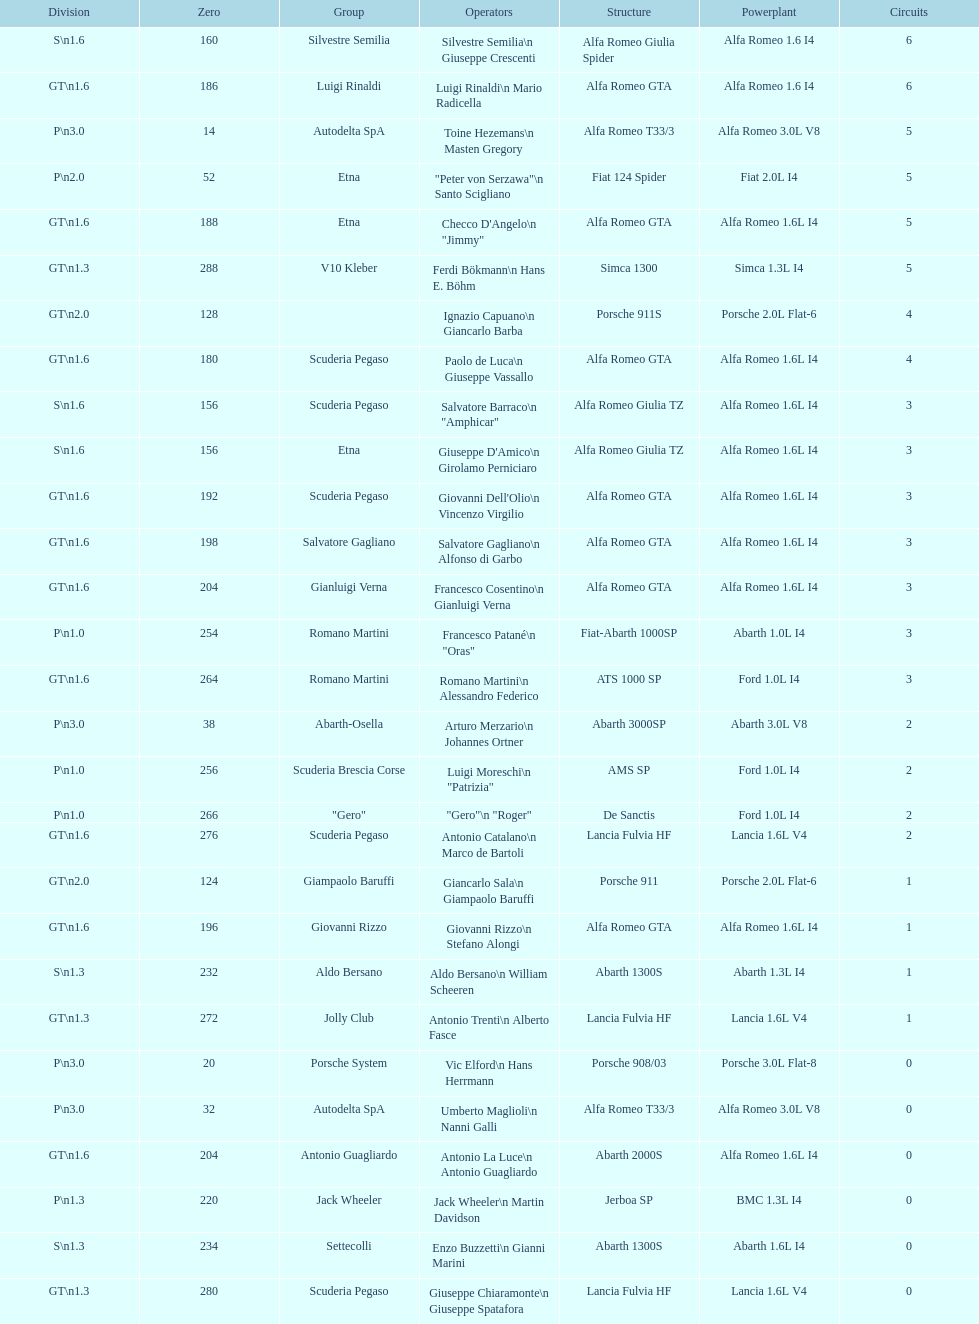Name the only american who did not finish the race. Masten Gregory. 